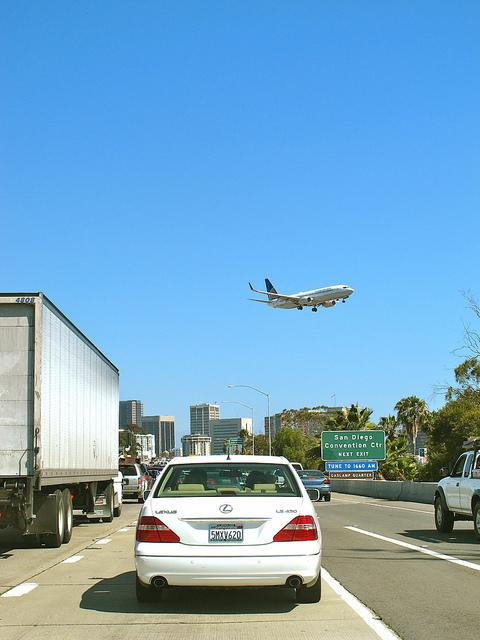This is most likely a scene from which major California city?

Choices:
A) san francisco
B) san diego
C) la
D) pasadena san diego 